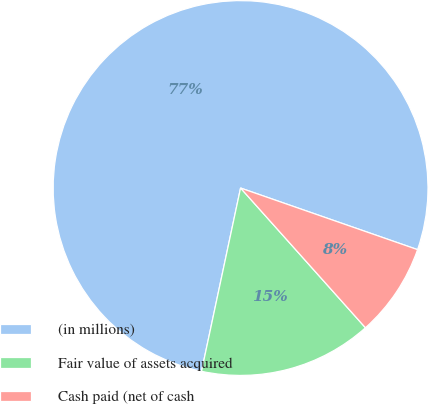Convert chart. <chart><loc_0><loc_0><loc_500><loc_500><pie_chart><fcel>(in millions)<fcel>Fair value of assets acquired<fcel>Cash paid (net of cash<nl><fcel>76.99%<fcel>14.95%<fcel>8.06%<nl></chart> 